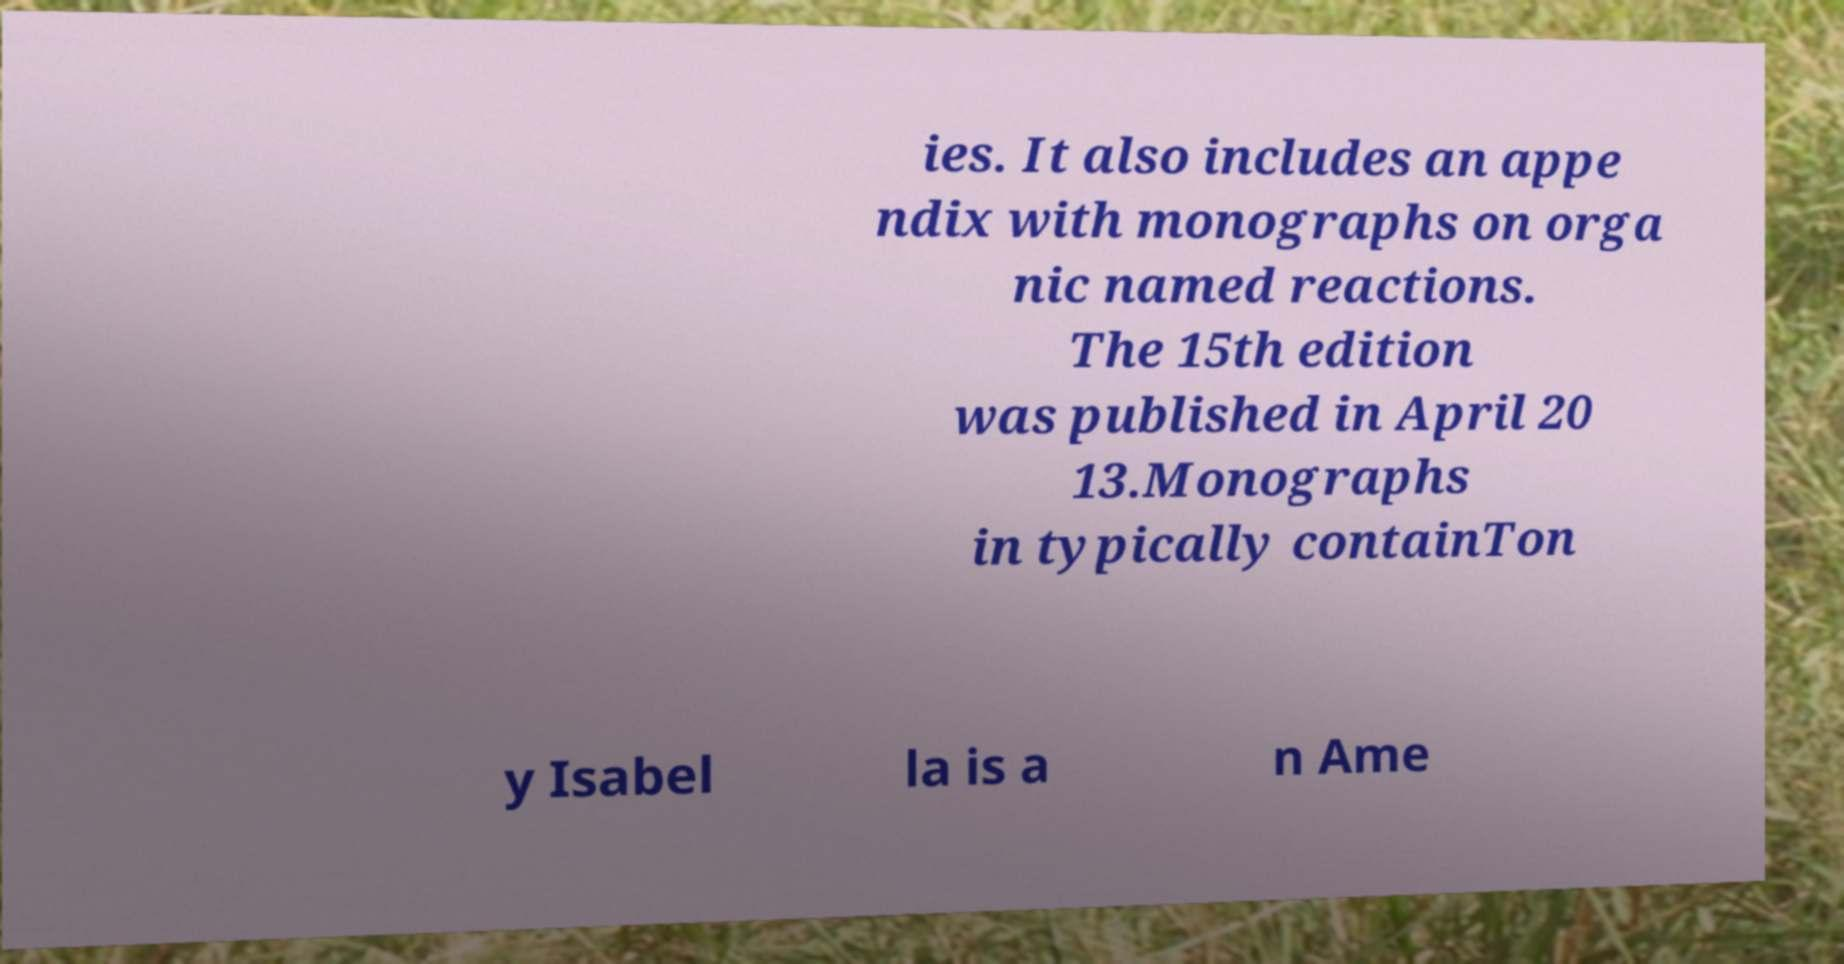Can you read and provide the text displayed in the image?This photo seems to have some interesting text. Can you extract and type it out for me? ies. It also includes an appe ndix with monographs on orga nic named reactions. The 15th edition was published in April 20 13.Monographs in typically containTon y Isabel la is a n Ame 